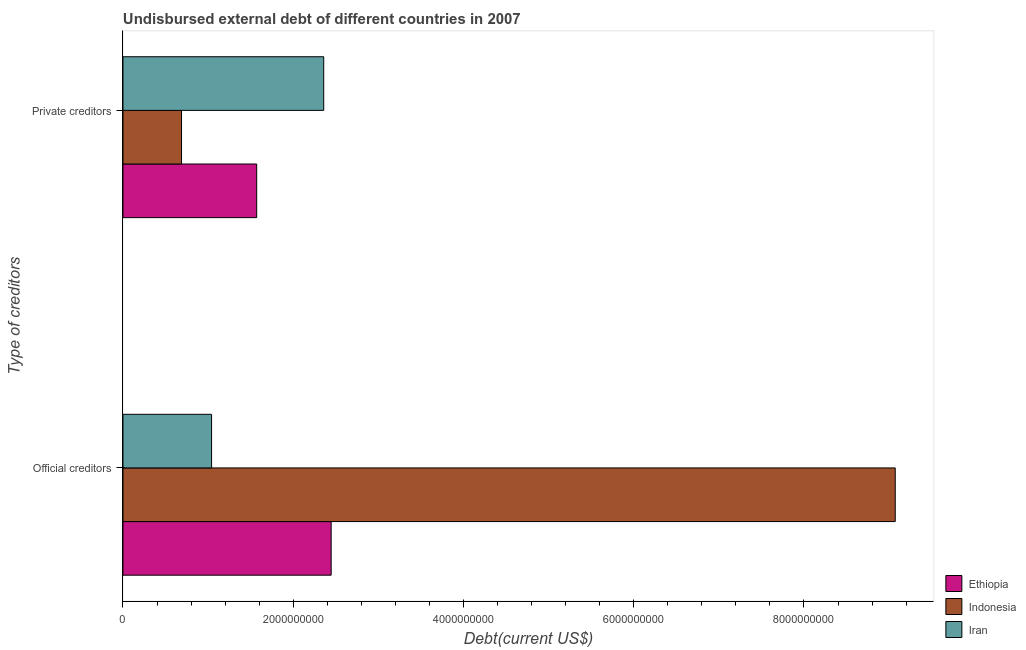What is the label of the 1st group of bars from the top?
Keep it short and to the point. Private creditors. What is the undisbursed external debt of private creditors in Iran?
Your answer should be very brief. 2.36e+09. Across all countries, what is the maximum undisbursed external debt of official creditors?
Provide a succinct answer. 9.07e+09. Across all countries, what is the minimum undisbursed external debt of private creditors?
Give a very brief answer. 6.88e+08. In which country was the undisbursed external debt of official creditors maximum?
Your answer should be very brief. Indonesia. In which country was the undisbursed external debt of official creditors minimum?
Offer a terse response. Iran. What is the total undisbursed external debt of official creditors in the graph?
Offer a very short reply. 1.26e+1. What is the difference between the undisbursed external debt of official creditors in Ethiopia and that in Indonesia?
Ensure brevity in your answer.  -6.63e+09. What is the difference between the undisbursed external debt of official creditors in Ethiopia and the undisbursed external debt of private creditors in Iran?
Your answer should be compact. 8.74e+07. What is the average undisbursed external debt of official creditors per country?
Your answer should be compact. 4.19e+09. What is the difference between the undisbursed external debt of official creditors and undisbursed external debt of private creditors in Indonesia?
Your response must be concise. 8.38e+09. What is the ratio of the undisbursed external debt of private creditors in Iran to that in Ethiopia?
Your answer should be compact. 1.5. In how many countries, is the undisbursed external debt of private creditors greater than the average undisbursed external debt of private creditors taken over all countries?
Your answer should be compact. 2. What does the 3rd bar from the bottom in Private creditors represents?
Keep it short and to the point. Iran. How many bars are there?
Your response must be concise. 6. How many countries are there in the graph?
Your answer should be very brief. 3. What is the difference between two consecutive major ticks on the X-axis?
Your response must be concise. 2.00e+09. Does the graph contain grids?
Make the answer very short. No. How many legend labels are there?
Your answer should be compact. 3. What is the title of the graph?
Provide a succinct answer. Undisbursed external debt of different countries in 2007. What is the label or title of the X-axis?
Provide a succinct answer. Debt(current US$). What is the label or title of the Y-axis?
Offer a very short reply. Type of creditors. What is the Debt(current US$) of Ethiopia in Official creditors?
Ensure brevity in your answer.  2.45e+09. What is the Debt(current US$) in Indonesia in Official creditors?
Your answer should be very brief. 9.07e+09. What is the Debt(current US$) of Iran in Official creditors?
Your answer should be compact. 1.04e+09. What is the Debt(current US$) of Ethiopia in Private creditors?
Your answer should be compact. 1.57e+09. What is the Debt(current US$) of Indonesia in Private creditors?
Offer a terse response. 6.88e+08. What is the Debt(current US$) of Iran in Private creditors?
Give a very brief answer. 2.36e+09. Across all Type of creditors, what is the maximum Debt(current US$) of Ethiopia?
Your response must be concise. 2.45e+09. Across all Type of creditors, what is the maximum Debt(current US$) of Indonesia?
Ensure brevity in your answer.  9.07e+09. Across all Type of creditors, what is the maximum Debt(current US$) in Iran?
Ensure brevity in your answer.  2.36e+09. Across all Type of creditors, what is the minimum Debt(current US$) of Ethiopia?
Provide a short and direct response. 1.57e+09. Across all Type of creditors, what is the minimum Debt(current US$) in Indonesia?
Provide a short and direct response. 6.88e+08. Across all Type of creditors, what is the minimum Debt(current US$) of Iran?
Provide a succinct answer. 1.04e+09. What is the total Debt(current US$) in Ethiopia in the graph?
Your answer should be compact. 4.02e+09. What is the total Debt(current US$) of Indonesia in the graph?
Your response must be concise. 9.76e+09. What is the total Debt(current US$) in Iran in the graph?
Your response must be concise. 3.40e+09. What is the difference between the Debt(current US$) in Ethiopia in Official creditors and that in Private creditors?
Ensure brevity in your answer.  8.75e+08. What is the difference between the Debt(current US$) in Indonesia in Official creditors and that in Private creditors?
Provide a succinct answer. 8.38e+09. What is the difference between the Debt(current US$) of Iran in Official creditors and that in Private creditors?
Your answer should be compact. -1.32e+09. What is the difference between the Debt(current US$) in Ethiopia in Official creditors and the Debt(current US$) in Indonesia in Private creditors?
Offer a very short reply. 1.76e+09. What is the difference between the Debt(current US$) of Ethiopia in Official creditors and the Debt(current US$) of Iran in Private creditors?
Offer a very short reply. 8.74e+07. What is the difference between the Debt(current US$) in Indonesia in Official creditors and the Debt(current US$) in Iran in Private creditors?
Your answer should be very brief. 6.71e+09. What is the average Debt(current US$) in Ethiopia per Type of creditors?
Provide a short and direct response. 2.01e+09. What is the average Debt(current US$) of Indonesia per Type of creditors?
Provide a succinct answer. 4.88e+09. What is the average Debt(current US$) in Iran per Type of creditors?
Make the answer very short. 1.70e+09. What is the difference between the Debt(current US$) in Ethiopia and Debt(current US$) in Indonesia in Official creditors?
Your answer should be very brief. -6.63e+09. What is the difference between the Debt(current US$) in Ethiopia and Debt(current US$) in Iran in Official creditors?
Offer a very short reply. 1.40e+09. What is the difference between the Debt(current US$) in Indonesia and Debt(current US$) in Iran in Official creditors?
Offer a terse response. 8.03e+09. What is the difference between the Debt(current US$) of Ethiopia and Debt(current US$) of Indonesia in Private creditors?
Keep it short and to the point. 8.83e+08. What is the difference between the Debt(current US$) of Ethiopia and Debt(current US$) of Iran in Private creditors?
Ensure brevity in your answer.  -7.87e+08. What is the difference between the Debt(current US$) in Indonesia and Debt(current US$) in Iran in Private creditors?
Ensure brevity in your answer.  -1.67e+09. What is the ratio of the Debt(current US$) in Ethiopia in Official creditors to that in Private creditors?
Your response must be concise. 1.56. What is the ratio of the Debt(current US$) of Indonesia in Official creditors to that in Private creditors?
Keep it short and to the point. 13.19. What is the ratio of the Debt(current US$) of Iran in Official creditors to that in Private creditors?
Provide a succinct answer. 0.44. What is the difference between the highest and the second highest Debt(current US$) in Ethiopia?
Provide a succinct answer. 8.75e+08. What is the difference between the highest and the second highest Debt(current US$) of Indonesia?
Give a very brief answer. 8.38e+09. What is the difference between the highest and the second highest Debt(current US$) of Iran?
Ensure brevity in your answer.  1.32e+09. What is the difference between the highest and the lowest Debt(current US$) in Ethiopia?
Give a very brief answer. 8.75e+08. What is the difference between the highest and the lowest Debt(current US$) of Indonesia?
Make the answer very short. 8.38e+09. What is the difference between the highest and the lowest Debt(current US$) of Iran?
Make the answer very short. 1.32e+09. 